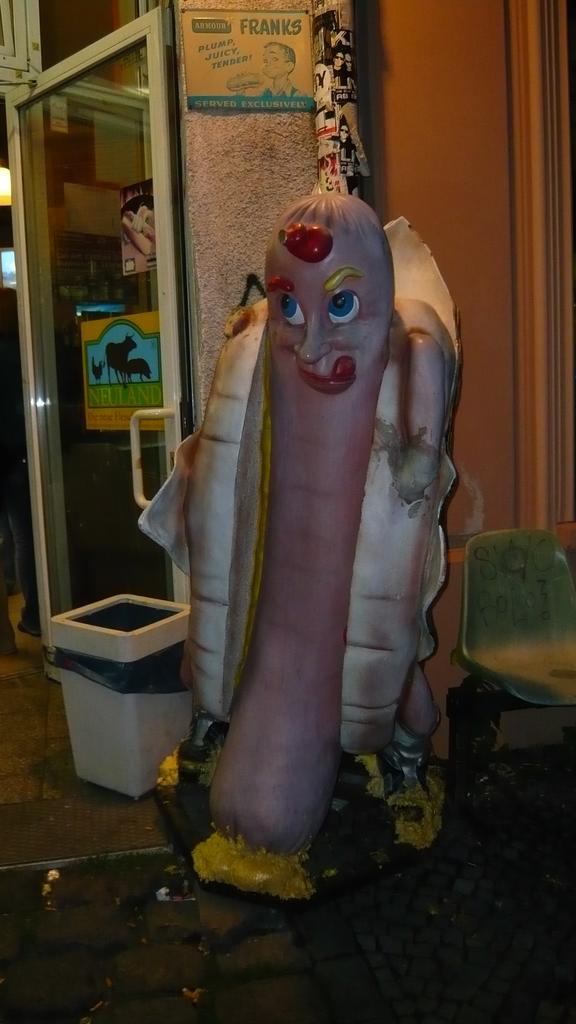What is on the ground in the image? There is a toy and a chair on the ground in the image. What can be seen in the background of the image? There is a wall, a door, posters, and some objects visible in the background of the image. What type of milk is being poured on the chin of the person in the image? There is no person or milk present in the image. 